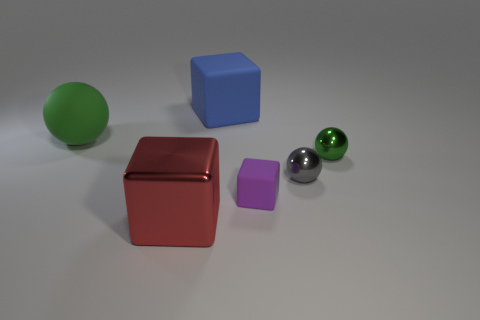Subtract all big matte balls. How many balls are left? 2 Add 1 big green objects. How many objects exist? 7 Subtract all gray spheres. How many spheres are left? 2 Subtract 2 blocks. How many blocks are left? 1 Add 4 metallic spheres. How many metallic spheres are left? 6 Add 4 big blue things. How many big blue things exist? 5 Subtract 1 blue cubes. How many objects are left? 5 Subtract all cyan balls. Subtract all yellow cylinders. How many balls are left? 3 Subtract all yellow blocks. How many gray spheres are left? 1 Subtract all big rubber objects. Subtract all red things. How many objects are left? 3 